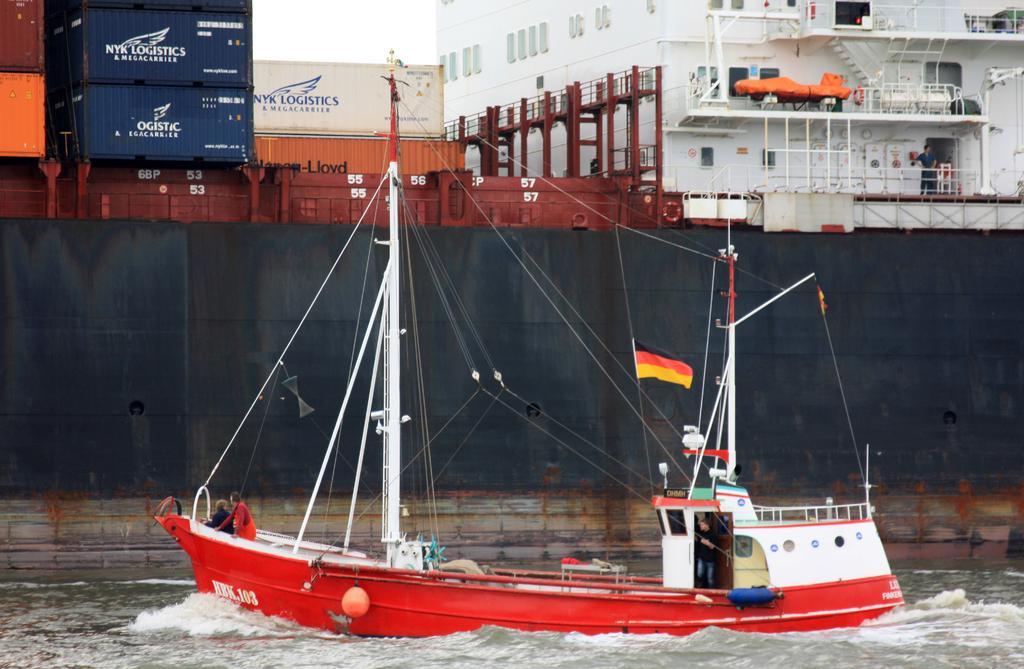Describe this image in one or two sentences. There is a ship in the center of the image, on the water surface, there are people in it and there are containers, building structure, the man and sky in the background area. 